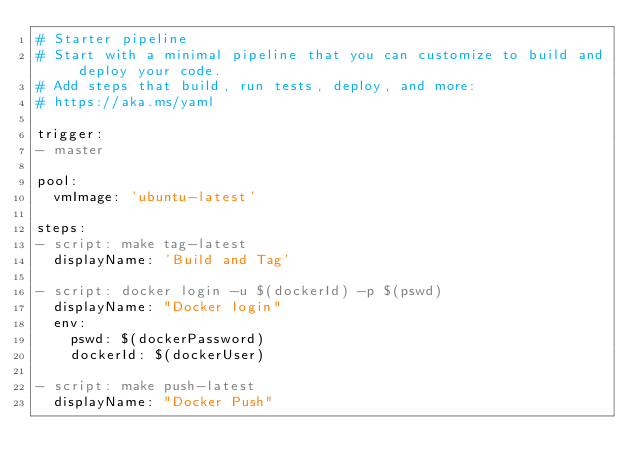Convert code to text. <code><loc_0><loc_0><loc_500><loc_500><_YAML_># Starter pipeline
# Start with a minimal pipeline that you can customize to build and deploy your code.
# Add steps that build, run tests, deploy, and more:
# https://aka.ms/yaml

trigger:
- master

pool:
  vmImage: 'ubuntu-latest'

steps:
- script: make tag-latest
  displayName: 'Build and Tag'

- script: docker login -u $(dockerId) -p $(pswd) 
  displayName: "Docker login"
  env:
    pswd: $(dockerPassword)
    dockerId: $(dockerUser)

- script: make push-latest
  displayName: "Docker Push"</code> 